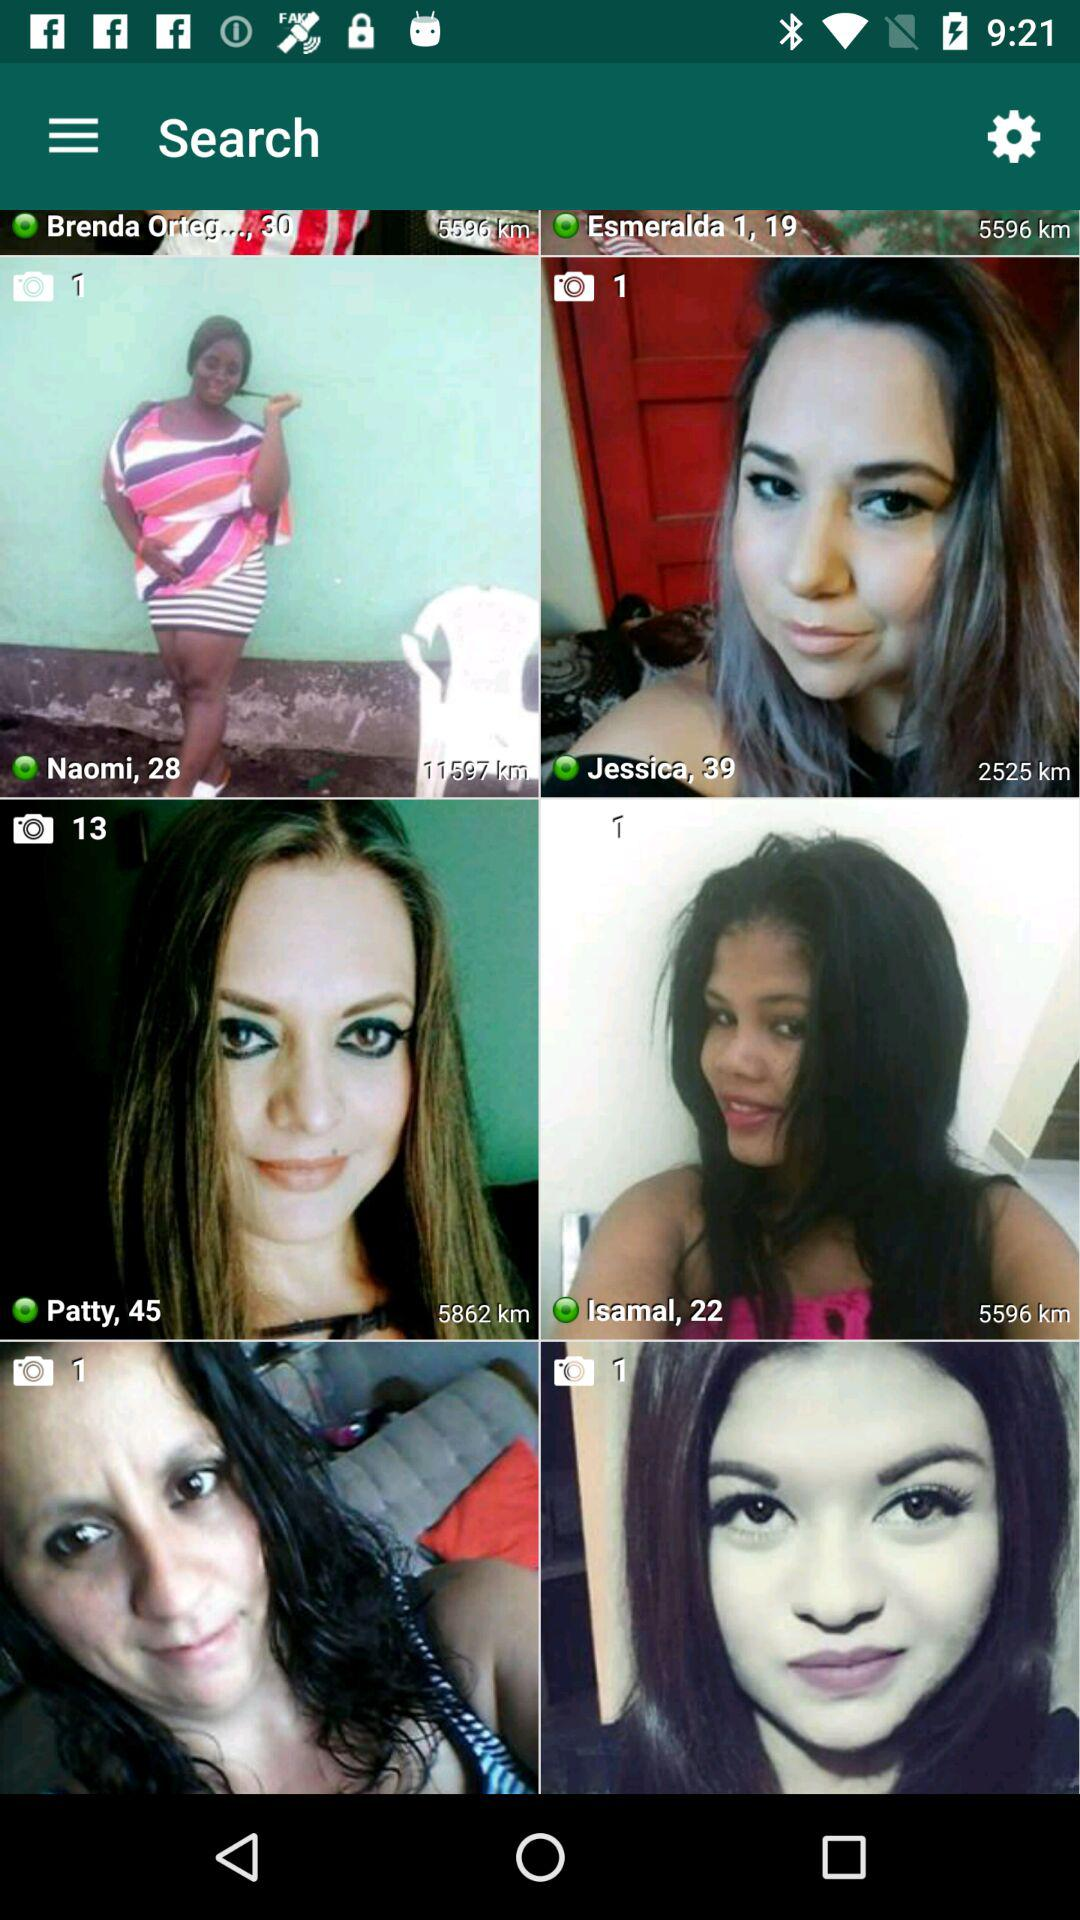How old is Jessica? Jessica is 39 years old. 